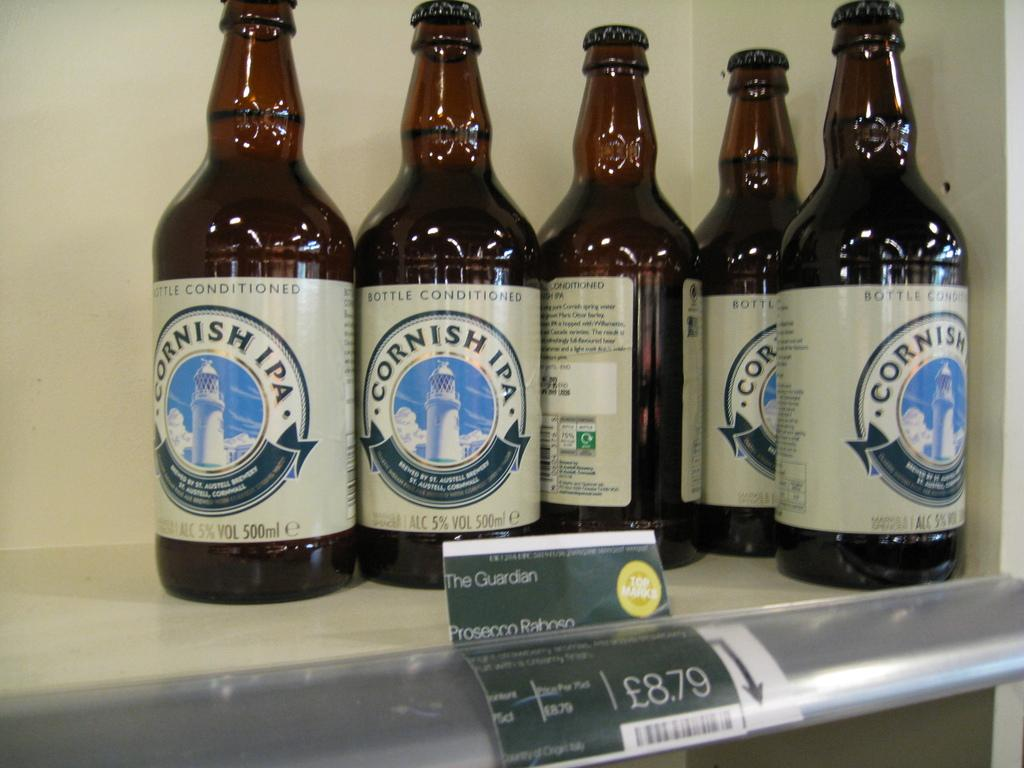<image>
Relay a brief, clear account of the picture shown. Several bottles of Cornish IPA are on a shelf. 